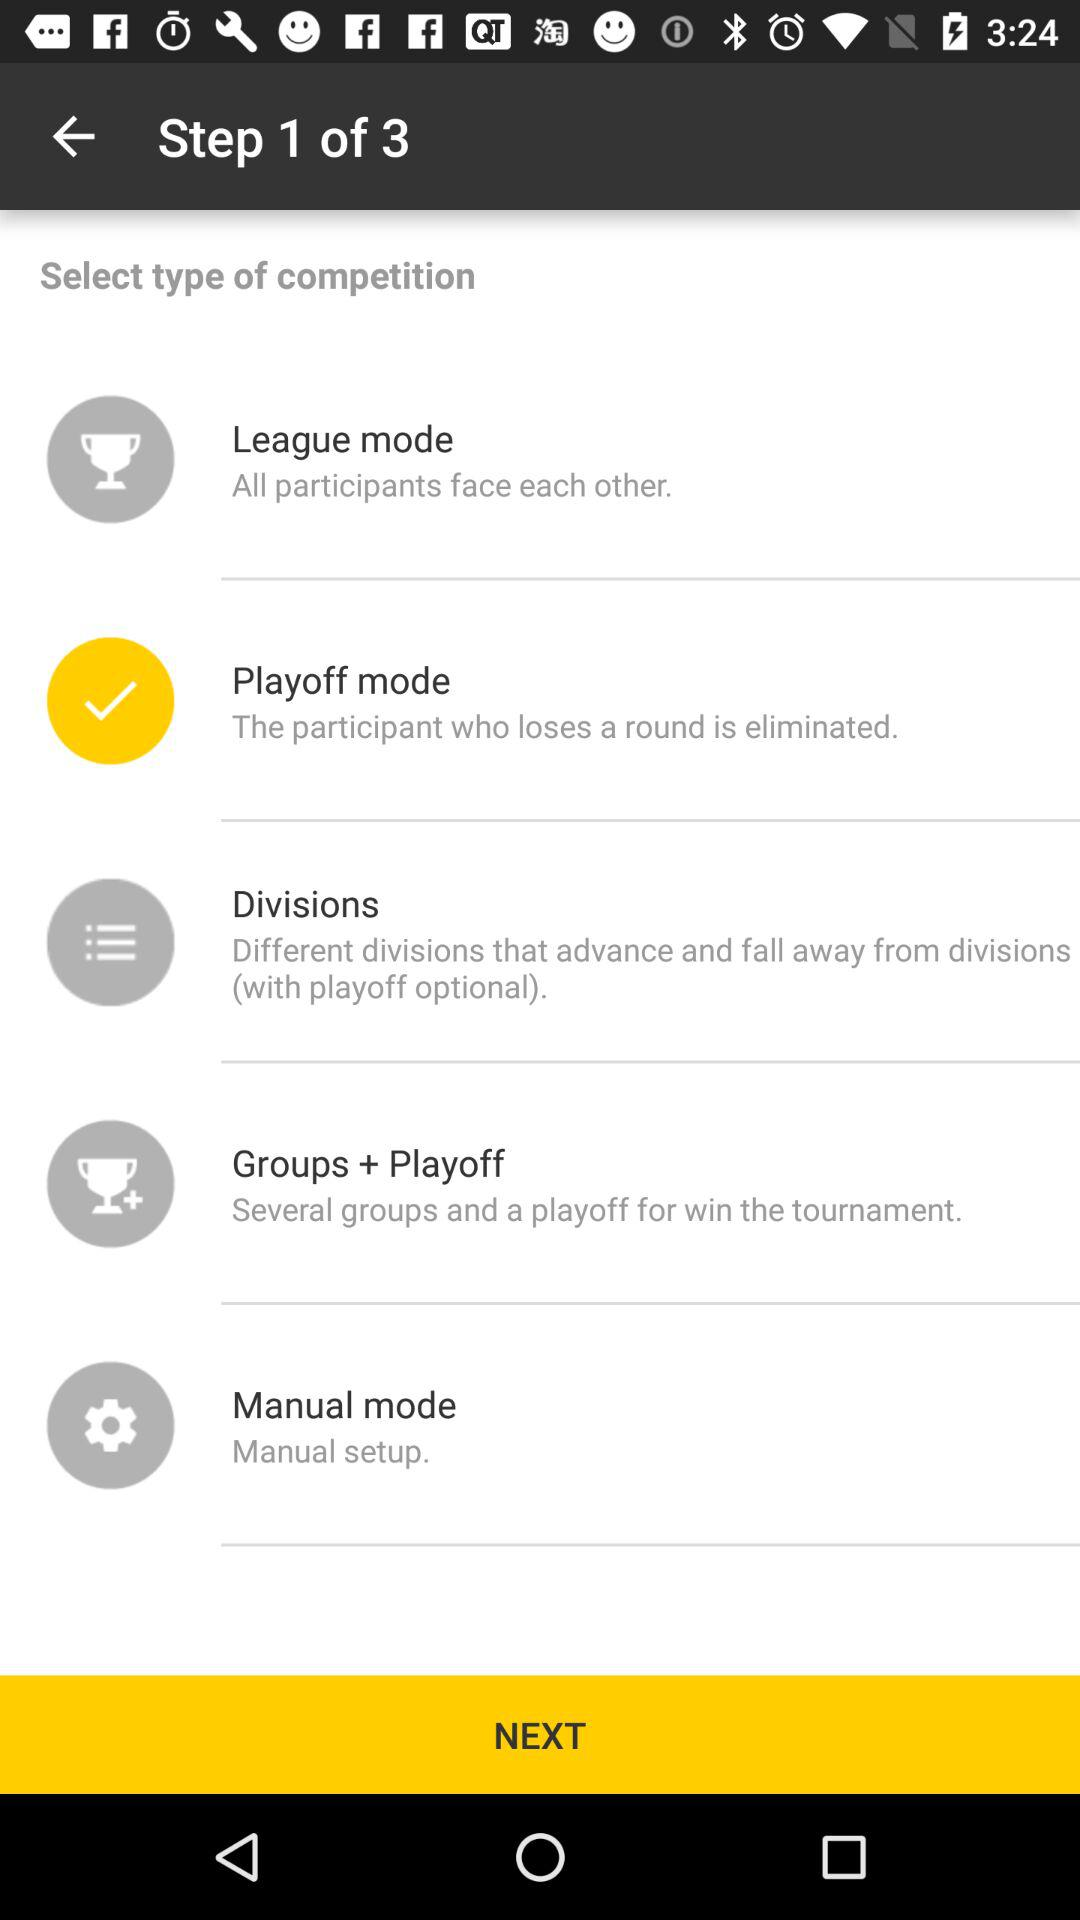How many of the competition modes include a playoff?
Answer the question using a single word or phrase. 2 